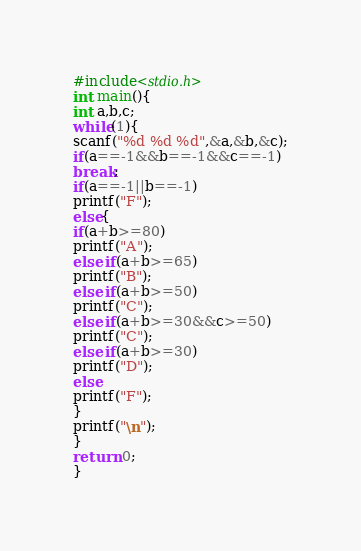Convert code to text. <code><loc_0><loc_0><loc_500><loc_500><_C_>#include<stdio.h>
int main(){
int a,b,c;
while(1){
scanf("%d %d %d",&a,&b,&c);
if(a==-1&&b==-1&&c==-1)
break;
if(a==-1||b==-1)
printf("F");
else{
if(a+b>=80)
printf("A");
else if(a+b>=65)
printf("B");
else if(a+b>=50)
printf("C");
else if(a+b>=30&&c>=50)
printf("C");
else if(a+b>=30)
printf("D");
else
printf("F");
}
printf("\n");
}
return 0;
}</code> 